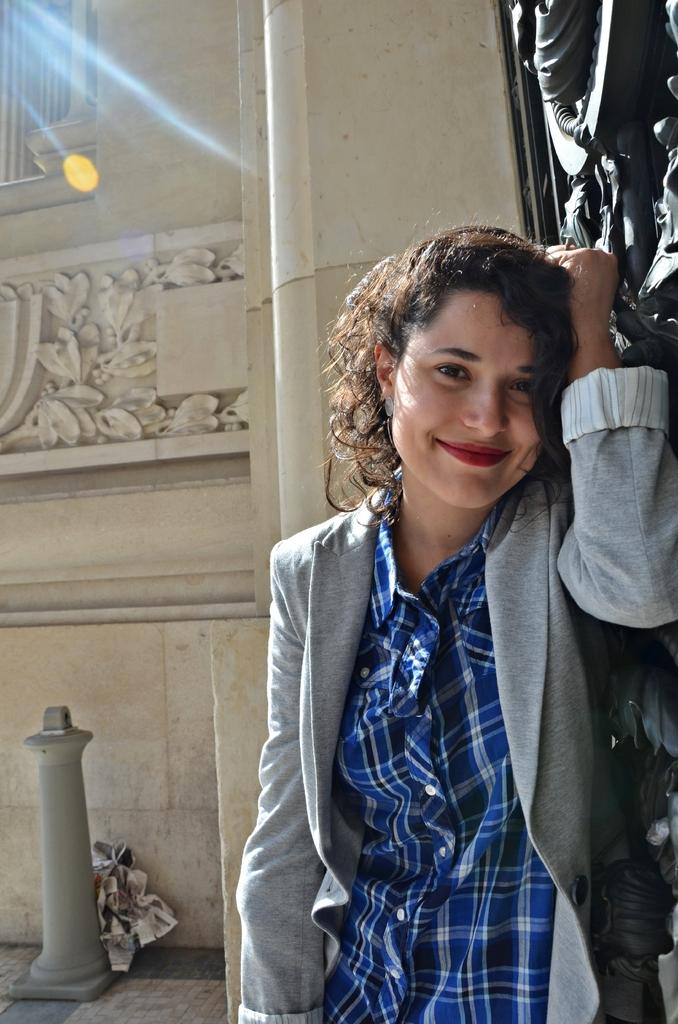Who is present in the image? There is a woman in the image. What is the woman doing in the image? The woman is standing and smiling. What can be seen on the floor in the bottom left side of the image? There is a pole on the floor in the bottom left side of the image. What is visible on the wall in the background of the image? There is a carving on the wall in the background of the image. What type of care does the woman need in the image? There is no indication in the image that the woman needs any care. What kind of jewel is the woman wearing in the image? There is no mention of a jewel in the image; the woman is simply standing and smiling. 